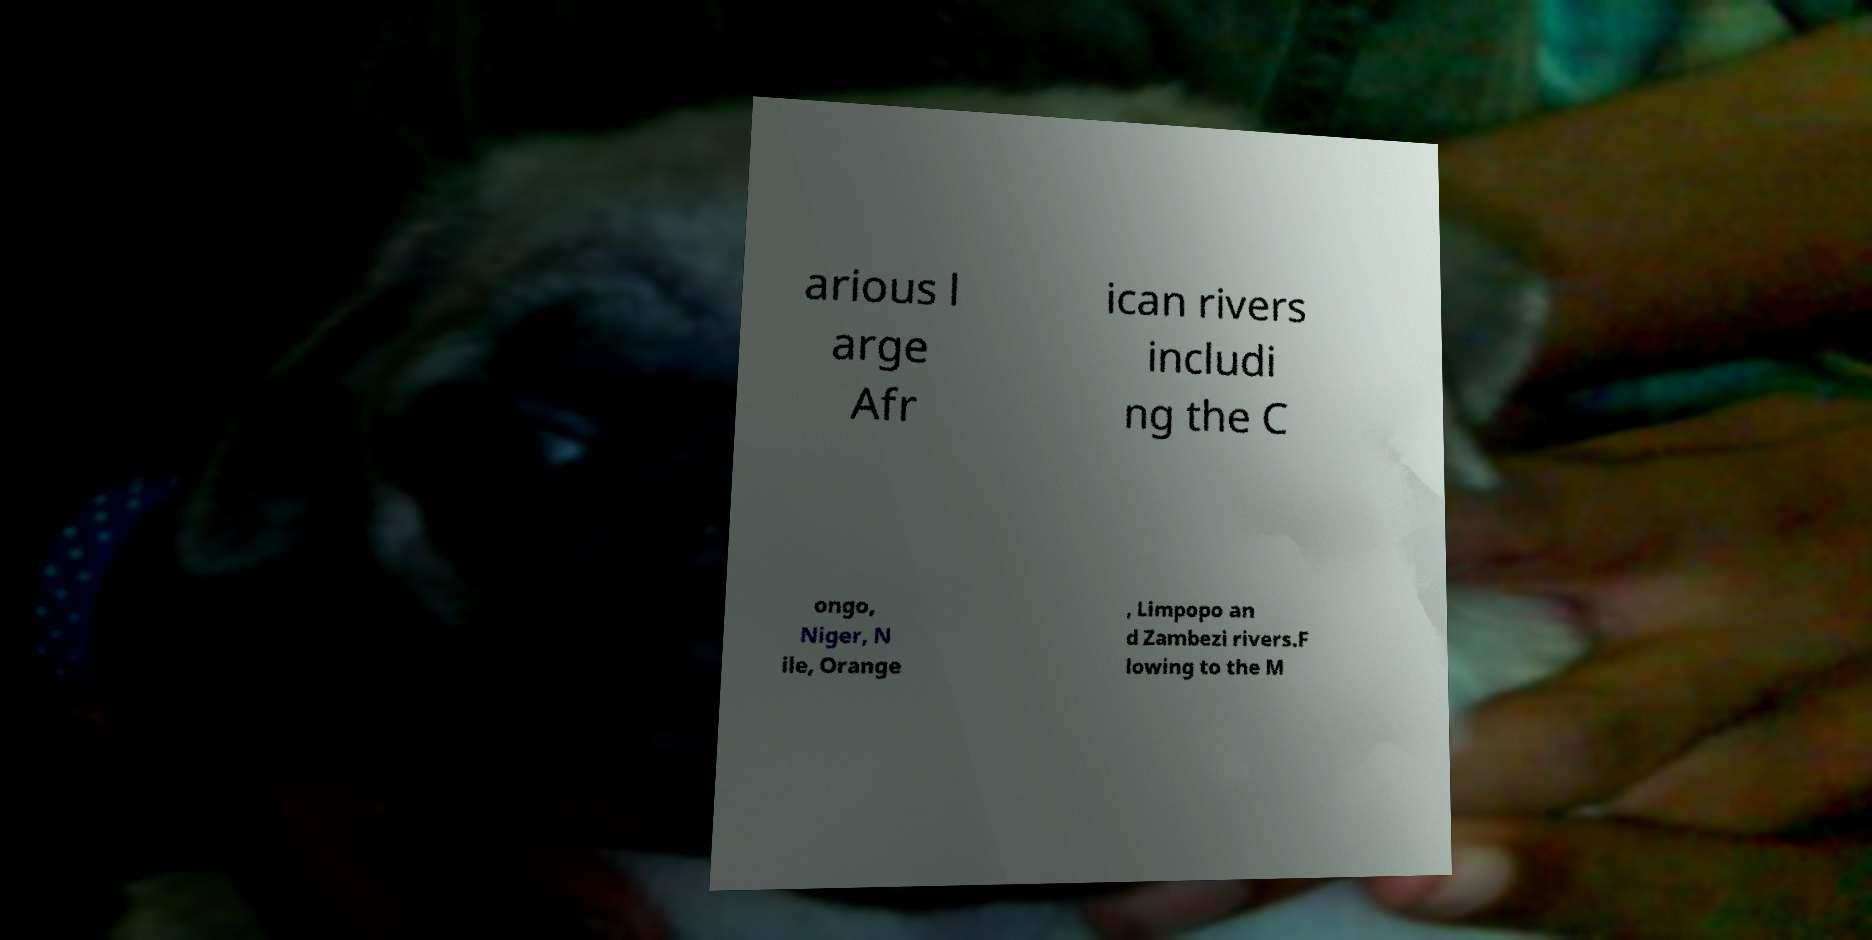Could you assist in decoding the text presented in this image and type it out clearly? arious l arge Afr ican rivers includi ng the C ongo, Niger, N ile, Orange , Limpopo an d Zambezi rivers.F lowing to the M 